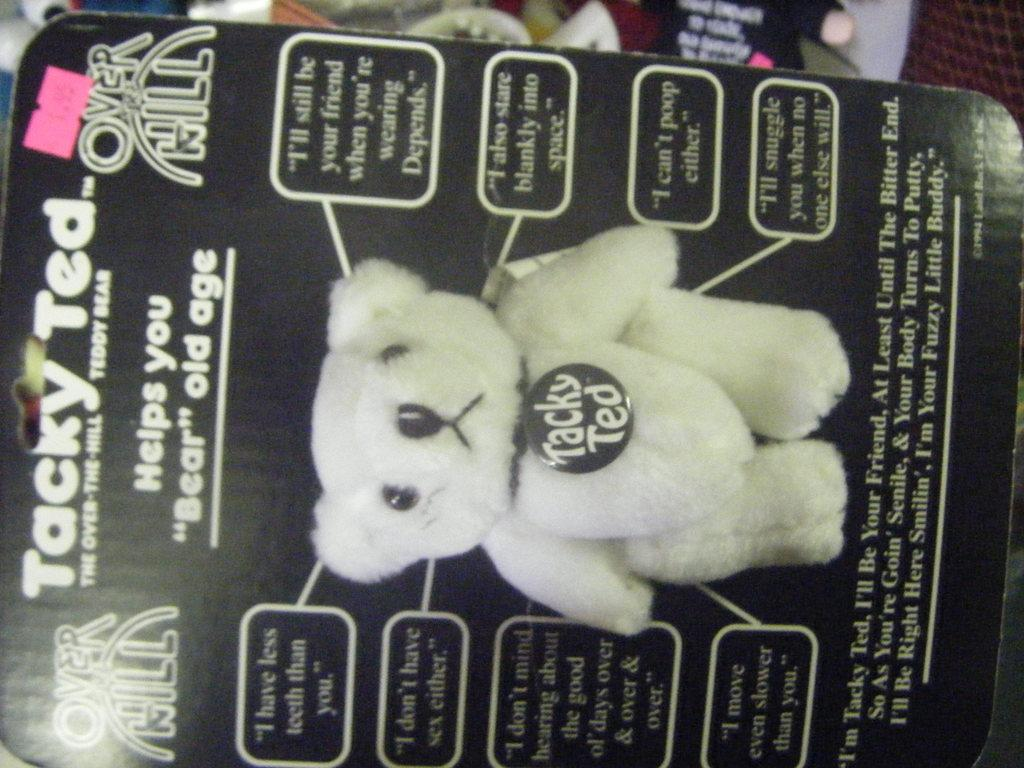What is the main object in the picture? There is a packaging box in the picture. What is the packaging box for? The packaging box is for a teddy bear. What can be seen on the packaging box? There is a photo of a teddy bear on the packaging box. Are there any words on the packaging box? Yes, there is text on the packaging box. Can you tell me how many roses are included in the packaging box? There are no roses mentioned or depicted in the packaging box; it is for a teddy bear. What type of oven is shown in the picture? There is no oven present in the picture; it features a packaging box for a teddy bear. 